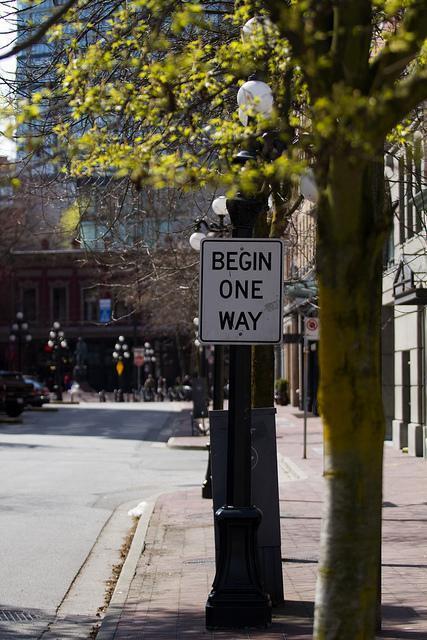How many suitcases do you see?
Give a very brief answer. 0. 